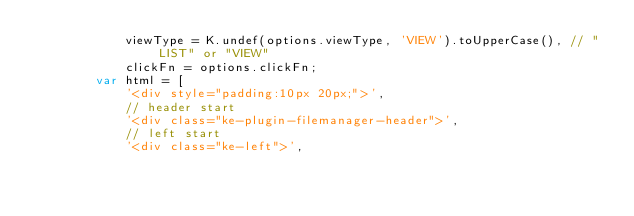<code> <loc_0><loc_0><loc_500><loc_500><_JavaScript_>			viewType = K.undef(options.viewType, 'VIEW').toUpperCase(), // "LIST" or "VIEW"
			clickFn = options.clickFn;
		var html = [
			'<div style="padding:10px 20px;">',
			// header start
			'<div class="ke-plugin-filemanager-header">',
			// left start
			'<div class="ke-left">',</code> 